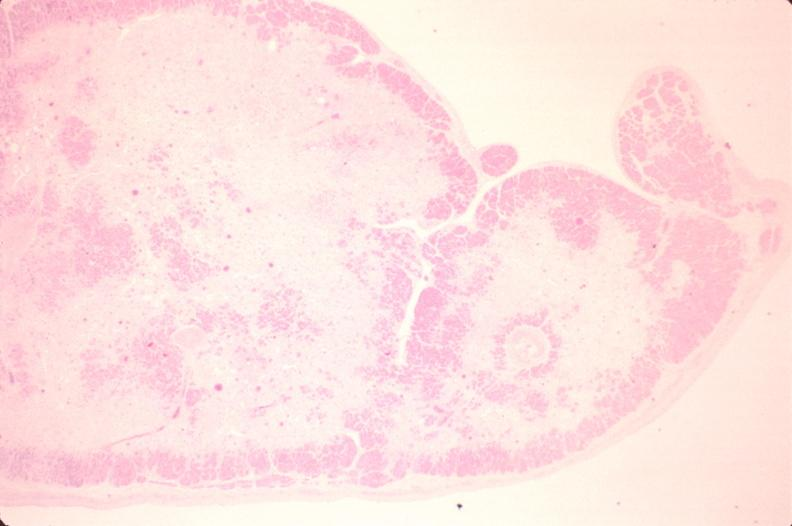does this image show heart, papillary muscle, fibrosis, chronic ischemic heart disease?
Answer the question using a single word or phrase. Yes 